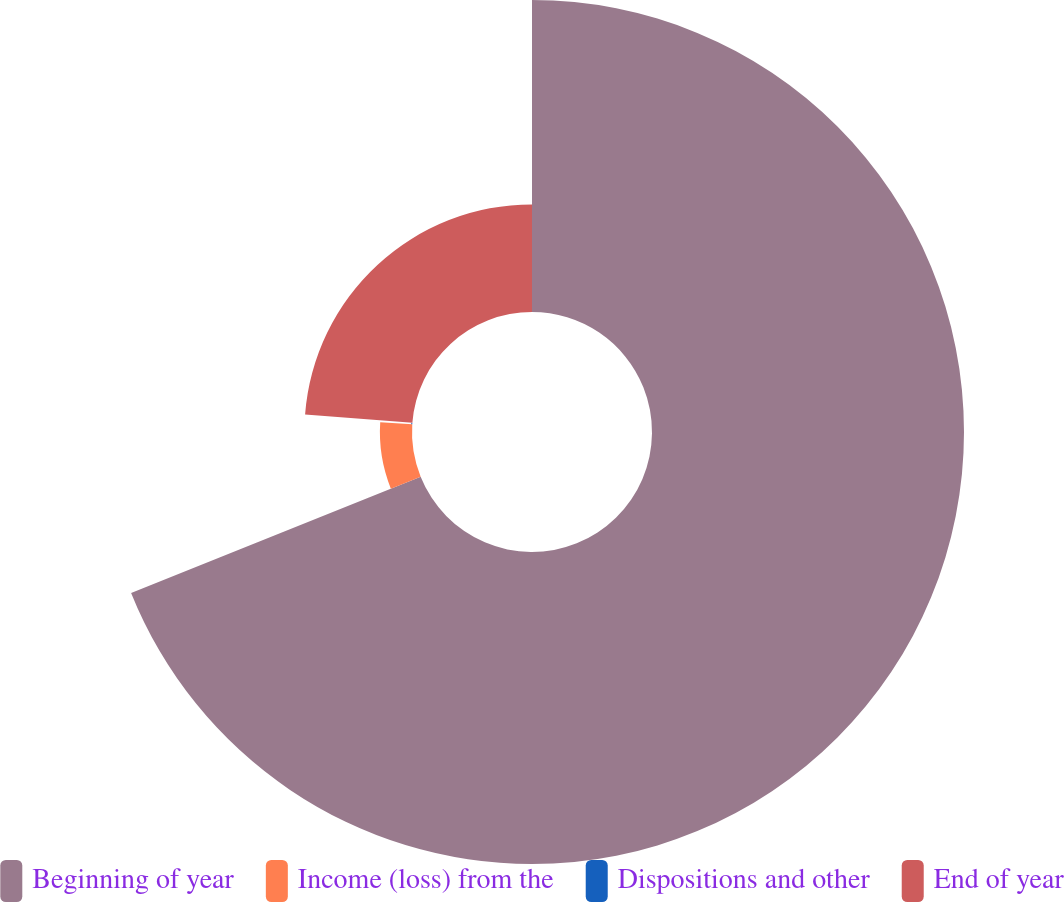Convert chart. <chart><loc_0><loc_0><loc_500><loc_500><pie_chart><fcel>Beginning of year<fcel>Income (loss) from the<fcel>Dispositions and other<fcel>End of year<nl><fcel>68.93%<fcel>7.09%<fcel>0.22%<fcel>23.77%<nl></chart> 